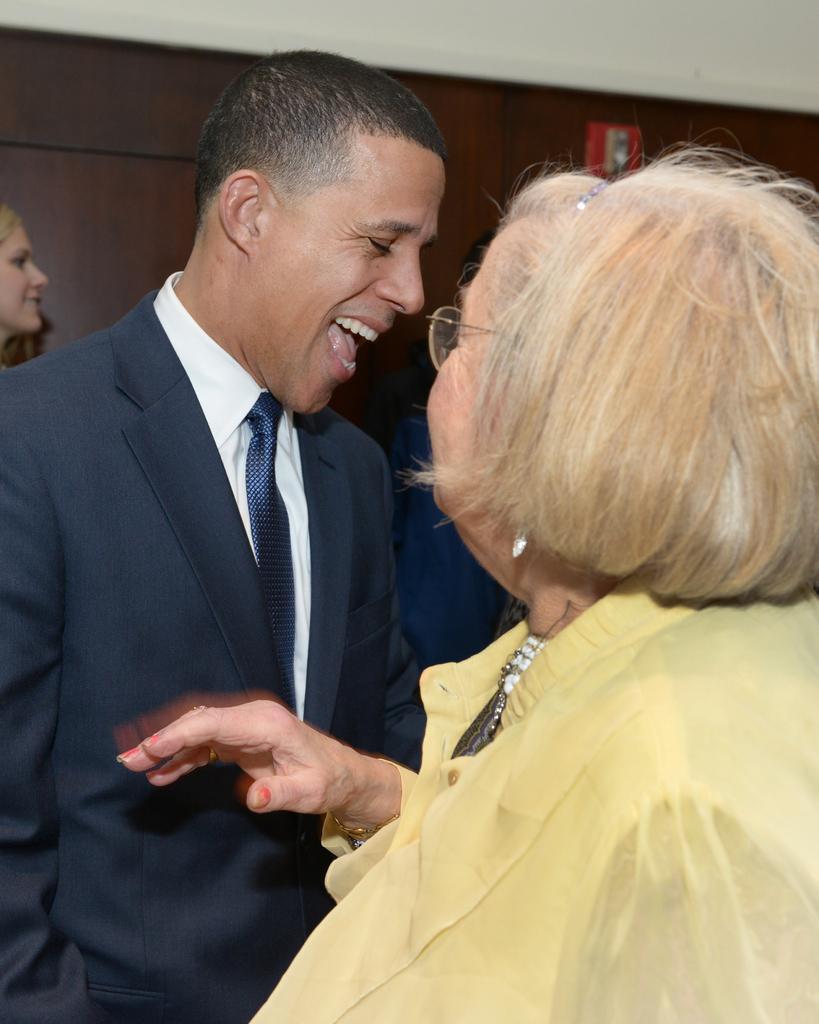Describe this image in one or two sentences. In the picture we can see a man standing and he is wearing a blue color blazer with tie and shirt and he is laughing and in front of him we can see a woman wearing a yellow color dress and looking at him and in the background we can see a wall which is brown in color. 